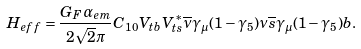<formula> <loc_0><loc_0><loc_500><loc_500>H _ { e f f } = \frac { G _ { F } \alpha _ { e m } } { 2 \sqrt { 2 } \pi } C _ { 1 0 } V _ { t b } V _ { t s } ^ { * } \overline { \nu } \gamma _ { \mu } ( 1 - \gamma _ { 5 } ) \nu \overline { s } \gamma _ { \mu } ( 1 - \gamma _ { 5 } ) b .</formula> 